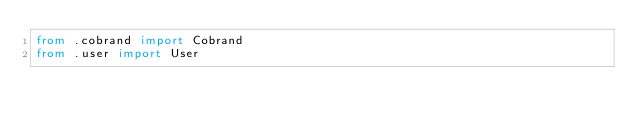Convert code to text. <code><loc_0><loc_0><loc_500><loc_500><_Python_>from .cobrand import Cobrand
from .user import User
</code> 